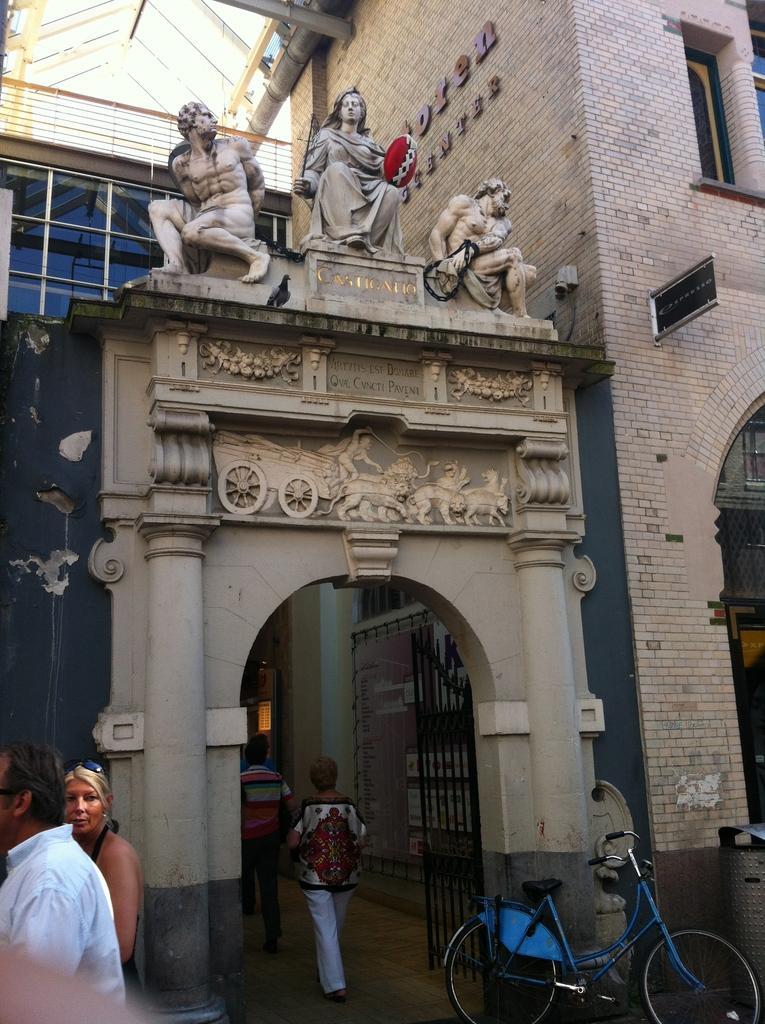Can you describe this image briefly? In this image I can see a building on the right side , in the middle I can see entrance gate and there are some persons entering into the gate , in front of the gate I can see a bi-cycle , on the gate I can see sculpture and on the left side I can see two persons 